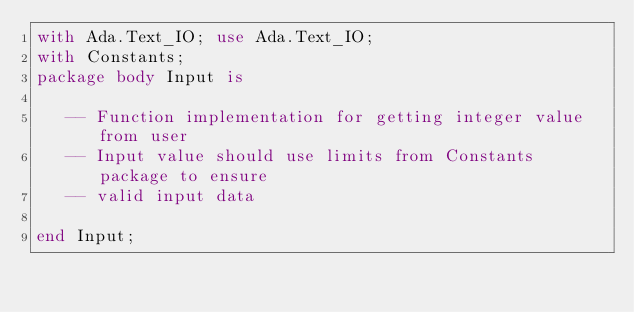<code> <loc_0><loc_0><loc_500><loc_500><_Ada_>with Ada.Text_IO; use Ada.Text_IO;
with Constants;
package body Input is

   -- Function implementation for getting integer value from user
   -- Input value should use limits from Constants package to ensure
   -- valid input data

end Input;
</code> 